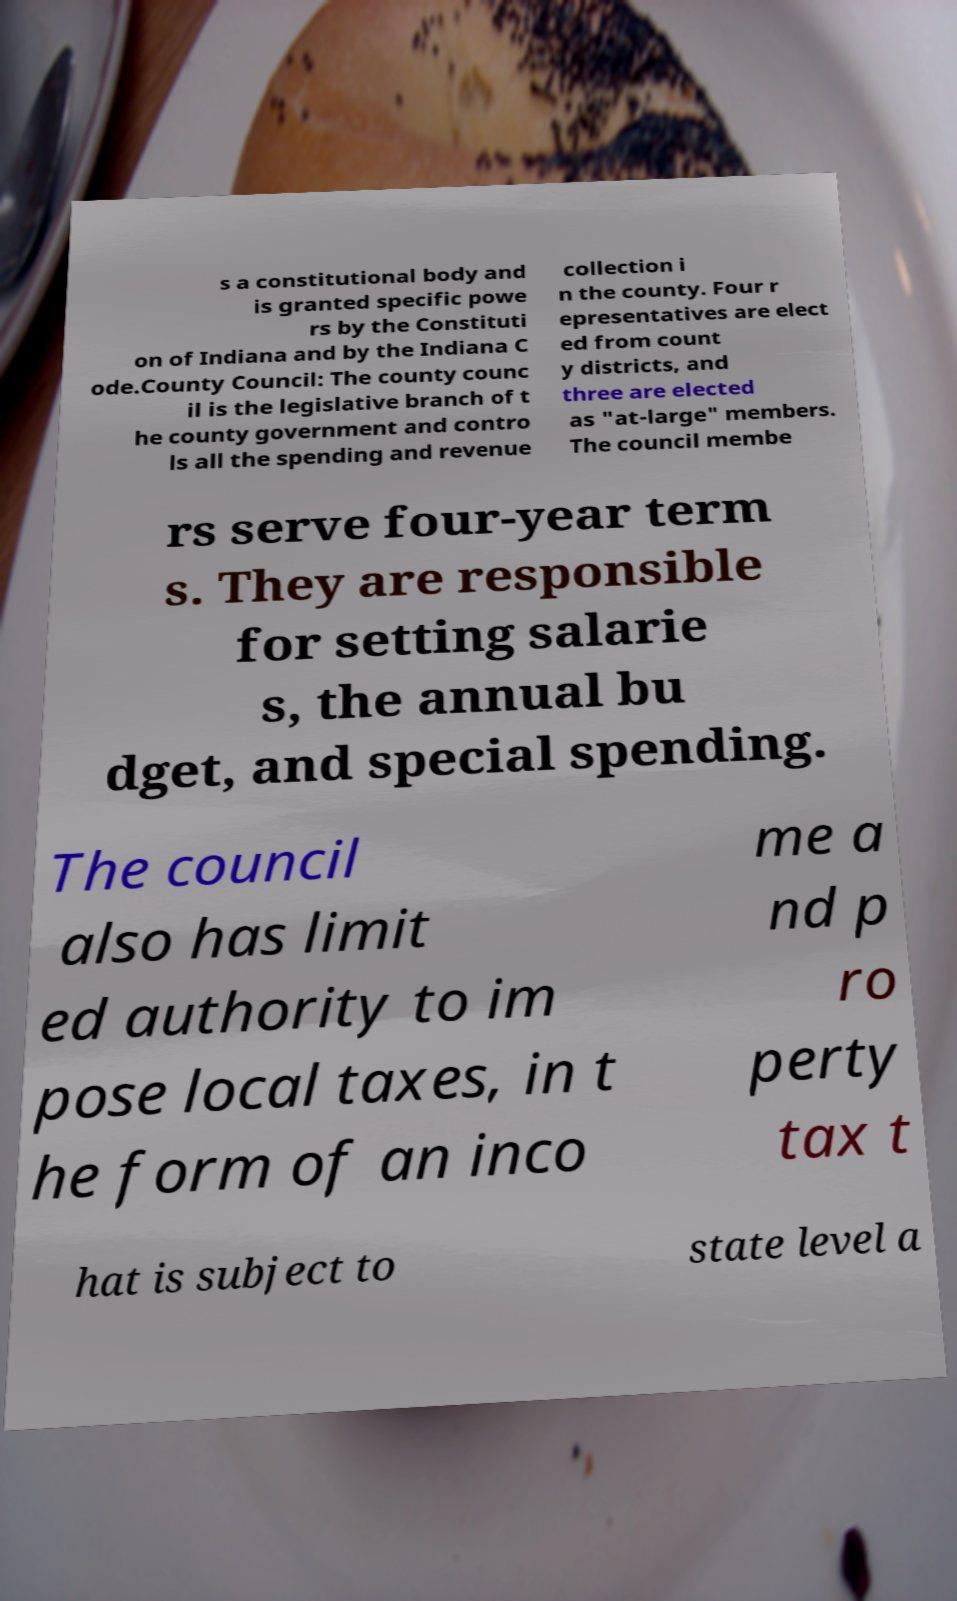Please read and relay the text visible in this image. What does it say? s a constitutional body and is granted specific powe rs by the Constituti on of Indiana and by the Indiana C ode.County Council: The county counc il is the legislative branch of t he county government and contro ls all the spending and revenue collection i n the county. Four r epresentatives are elect ed from count y districts, and three are elected as "at-large" members. The council membe rs serve four-year term s. They are responsible for setting salarie s, the annual bu dget, and special spending. The council also has limit ed authority to im pose local taxes, in t he form of an inco me a nd p ro perty tax t hat is subject to state level a 